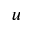<formula> <loc_0><loc_0><loc_500><loc_500>u</formula> 